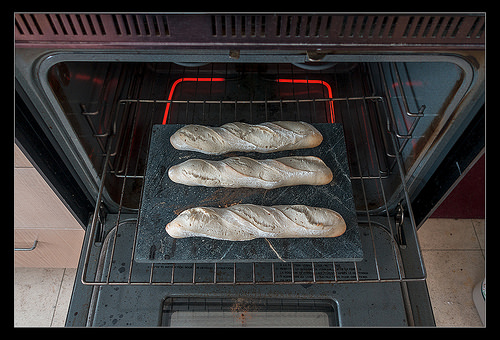<image>
Is the coil under the bread? Yes. The coil is positioned underneath the bread, with the bread above it in the vertical space. 